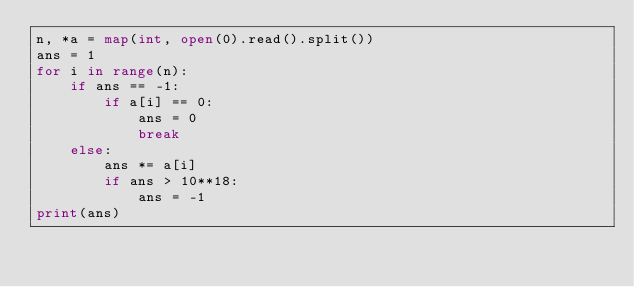Convert code to text. <code><loc_0><loc_0><loc_500><loc_500><_Python_>n, *a = map(int, open(0).read().split())
ans = 1
for i in range(n):
    if ans == -1:
        if a[i] == 0:
            ans = 0
            break
    else:
        ans *= a[i]
        if ans > 10**18:
            ans = -1
print(ans)
</code> 